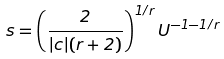Convert formula to latex. <formula><loc_0><loc_0><loc_500><loc_500>s = \left ( \frac { 2 } { | c | ( r + 2 ) } \right ) ^ { 1 / r } U ^ { - 1 - 1 / r }</formula> 